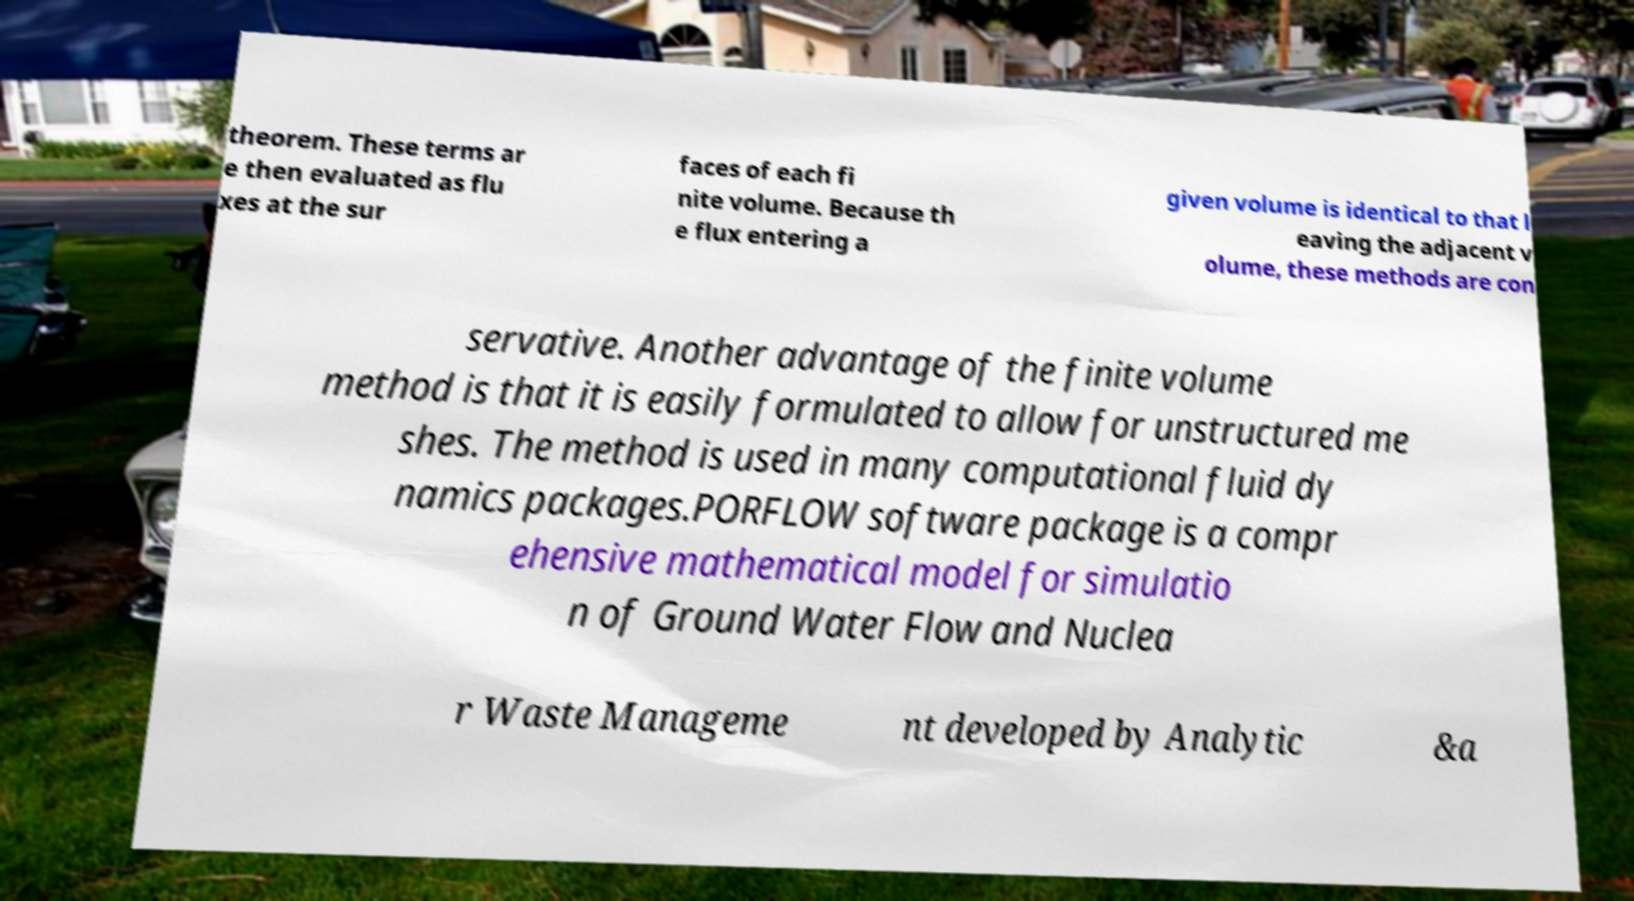Could you assist in decoding the text presented in this image and type it out clearly? theorem. These terms ar e then evaluated as flu xes at the sur faces of each fi nite volume. Because th e flux entering a given volume is identical to that l eaving the adjacent v olume, these methods are con servative. Another advantage of the finite volume method is that it is easily formulated to allow for unstructured me shes. The method is used in many computational fluid dy namics packages.PORFLOW software package is a compr ehensive mathematical model for simulatio n of Ground Water Flow and Nuclea r Waste Manageme nt developed by Analytic &a 